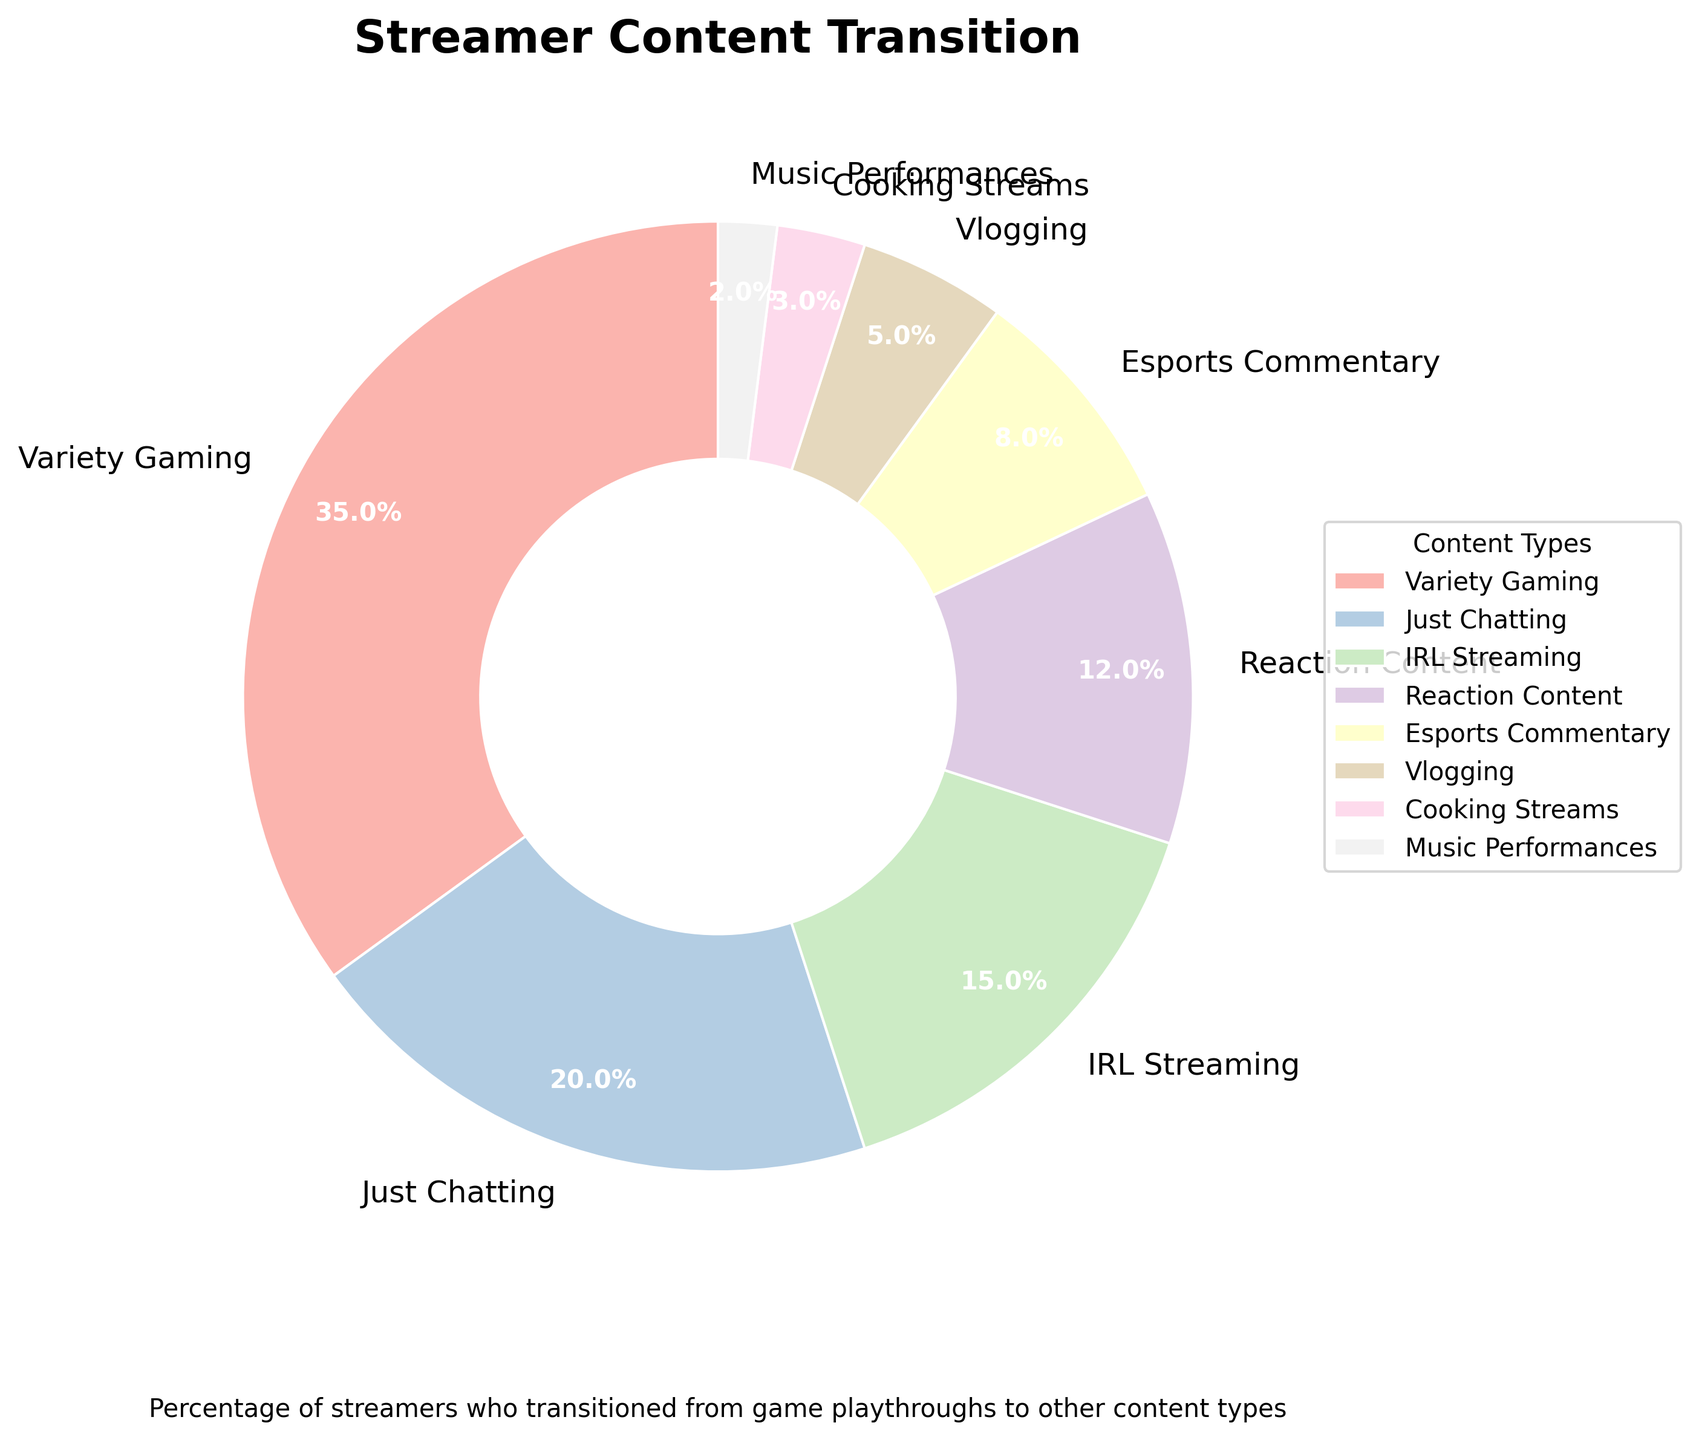What percentage of streamers transitioned to "Just Chatting"? Look at the pie chart for the section labeled "Just Chatting". The percentage is printed directly on the chart.
Answer: 20% Which content type has the largest percentage of streamers? By observing the pie chart, "Variety Gaming" has the largest section, and the percentage is printed on it.
Answer: Variety Gaming What are the combined percentages of "IRL Streaming" and "Reaction Content"? Add the percentages for "IRL Streaming" (15%) and "Reaction Content" (12%) from the pie chart.
Answer: 27% Which content type has the smallest percentage of streamers? By examining the pie chart, "Music Performances" has the smallest section, and the percentage is printed on it.
Answer: Music Performances How many more streamers transitioned to "Esports Commentary" than to "Cooking Streams"? Subtract the percentage of "Cooking Streams" (3%) from "Esports Commentary" (8%) as shown in the pie chart.
Answer: 5% Which content type has a percentage that is half of "Variety Gaming"? Compare "Variety Gaming" (35%) with other percentages. "Just Chatting" is 20% (more than half), so "IRL Streaming" (15%) is closest to half of "Variety Gaming".
Answer: IRL Streaming What percentage of streamers transitioned to content types that have examples starting with a letter other than "V" or "C"? Sum the percentages for "Just Chatting" (20%), "IRL Streaming" (15%), "Reaction Content" (12%), "Esports Commentary" (8%), and "Music Performances" (2%).
Answer: 57% Is the section for "Vlogging" larger than the section for "Cooking Streams"? Visually compare the sizes of the sections for "Vlogging" and "Cooking Streams". "Vlogging" (5%) is larger than "Cooking Streams" (3%) on the pie chart.
Answer: Yes What is the difference in percentage between "Variety Gaming" and "Reaction Content"? Subtract the percentage of "Reaction Content" (12%) from "Variety Gaming" (35%) as shown in the pie chart.
Answer: 23% How does the percentage of "IRL Streaming" compare to that of "Vlogging" and "Cooking Streams" combined? Sum the percentages of "Vlogging" (5%) and "Cooking Streams" (3%), then compare it with "IRL Streaming" (15%).
Answer: IRL Streaming > Vlogging + Cooking Streams 